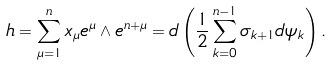Convert formula to latex. <formula><loc_0><loc_0><loc_500><loc_500>h = \sum _ { \mu = 1 } ^ { n } x _ { \mu } e ^ { \mu } \wedge e ^ { n + \mu } = d \left ( \frac { 1 } { 2 } \sum _ { k = 0 } ^ { n - 1 } \sigma _ { k + 1 } d \psi _ { k } \right ) .</formula> 